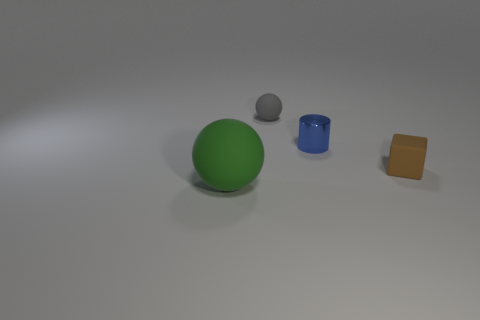Are there any other things that are the same shape as the small blue metal thing?
Provide a short and direct response. No. Is there any other thing that is the same size as the green matte sphere?
Keep it short and to the point. No. Does the tiny gray object have the same shape as the rubber thing in front of the brown block?
Offer a terse response. Yes. There is a object that is both on the left side of the cylinder and in front of the small metal object; what color is it?
Ensure brevity in your answer.  Green. Are there any other objects of the same shape as the large matte thing?
Your answer should be very brief. Yes. Is there a tiny blue object to the left of the big object that is in front of the small shiny thing?
Make the answer very short. No. What number of objects are tiny things on the right side of the gray thing or tiny things that are behind the tiny brown block?
Offer a terse response. 3. What number of objects are green spheres or tiny blue metallic cylinders to the right of the green matte sphere?
Keep it short and to the point. 2. How big is the ball that is in front of the tiny cylinder right of the rubber ball that is to the right of the big ball?
Offer a very short reply. Large. There is a gray ball that is the same size as the brown matte block; what is it made of?
Offer a terse response. Rubber. 